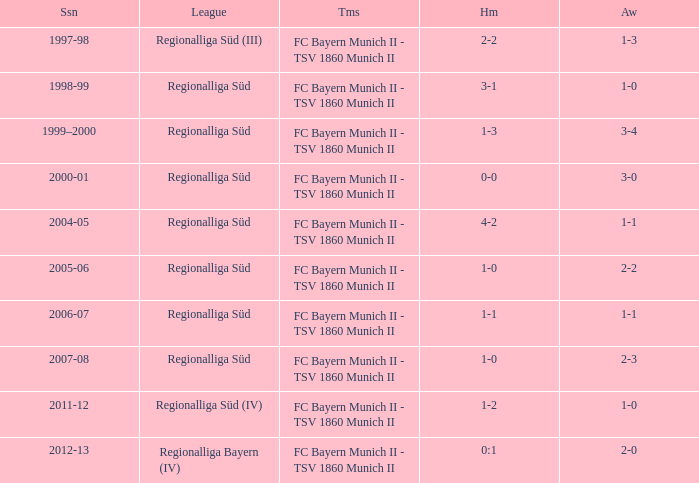What season has a regionalliga süd league, a 1-0 home, and an away of 2-3? 2007-08. 